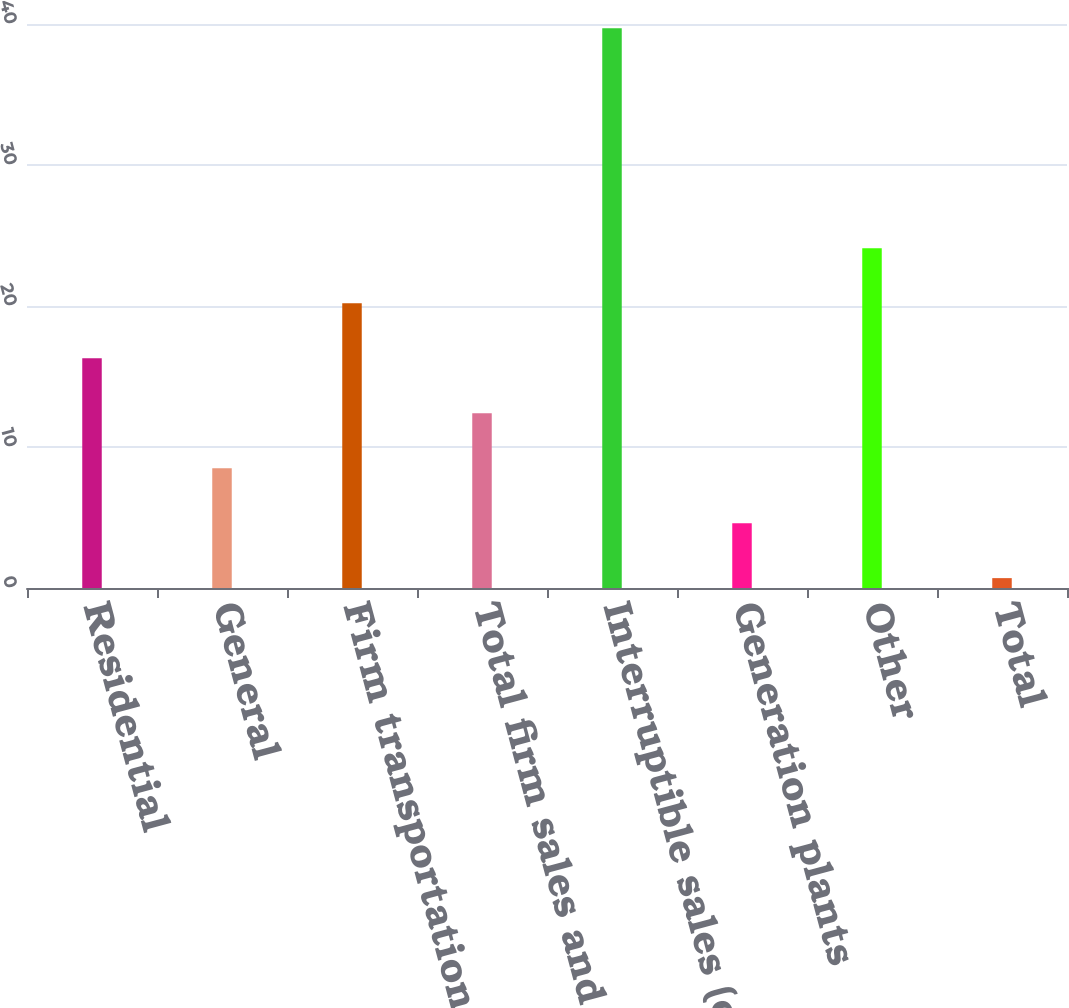<chart> <loc_0><loc_0><loc_500><loc_500><bar_chart><fcel>Residential<fcel>General<fcel>Firm transportation<fcel>Total firm sales and<fcel>Interruptible sales (c)<fcel>Generation plants<fcel>Other<fcel>Total<nl><fcel>16.3<fcel>8.5<fcel>20.2<fcel>12.4<fcel>39.7<fcel>4.6<fcel>24.1<fcel>0.7<nl></chart> 